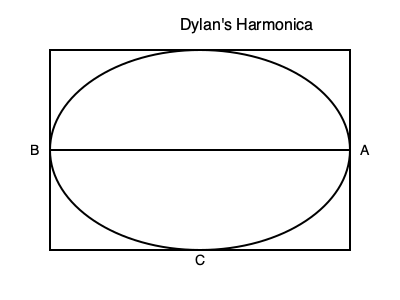If Dylan's harmonica is represented by the 3D shape above, what shape would the cross-section be if cut along line AB? To determine the shape of the cross-section, we need to analyze the 3D representation of Dylan's harmonica:

1. The outer shape is a rectangular prism, as indicated by the rectangular outline.
2. The ellipse inside suggests that the harmonica has a cylindrical or elliptical cylindrical body.
3. Line AB cuts through the middle of the shape horizontally.

Given this information:

1. The cross-section along AB would cut through the width of the rectangular prism, resulting in a rectangle.
2. It would also intersect the elliptical cylinder at its widest point.
3. The intersection of a plane with a cylinder perpendicular to its axis creates a circle.

Therefore, the cross-section would be a rectangle with a circle inside it. The circle represents the inner chamber of the harmonica, while the rectangle represents the outer casing.
Answer: Rectangle with a circle inside 